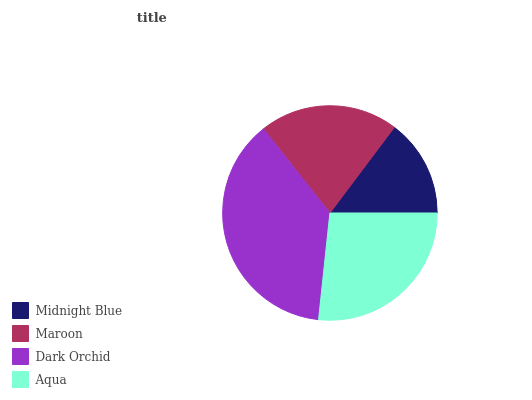Is Midnight Blue the minimum?
Answer yes or no. Yes. Is Dark Orchid the maximum?
Answer yes or no. Yes. Is Maroon the minimum?
Answer yes or no. No. Is Maroon the maximum?
Answer yes or no. No. Is Maroon greater than Midnight Blue?
Answer yes or no. Yes. Is Midnight Blue less than Maroon?
Answer yes or no. Yes. Is Midnight Blue greater than Maroon?
Answer yes or no. No. Is Maroon less than Midnight Blue?
Answer yes or no. No. Is Aqua the high median?
Answer yes or no. Yes. Is Maroon the low median?
Answer yes or no. Yes. Is Midnight Blue the high median?
Answer yes or no. No. Is Dark Orchid the low median?
Answer yes or no. No. 